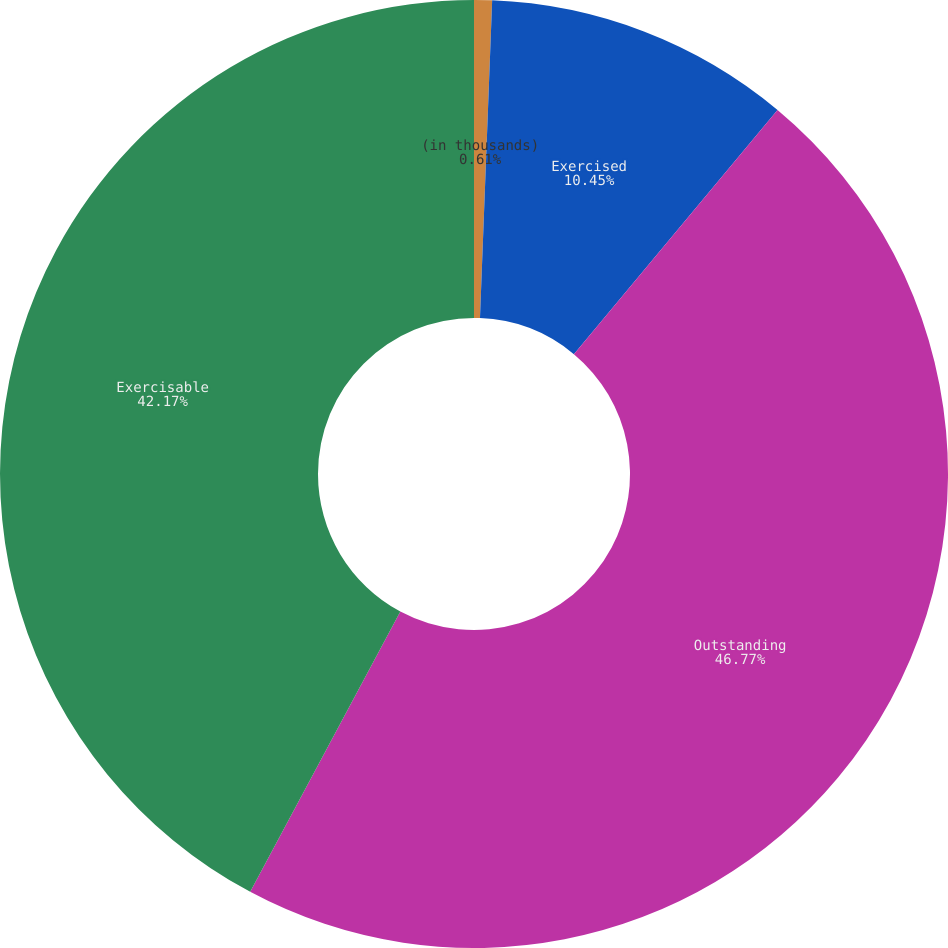Convert chart. <chart><loc_0><loc_0><loc_500><loc_500><pie_chart><fcel>(in thousands)<fcel>Exercised<fcel>Outstanding<fcel>Exercisable<nl><fcel>0.61%<fcel>10.45%<fcel>46.76%<fcel>42.17%<nl></chart> 